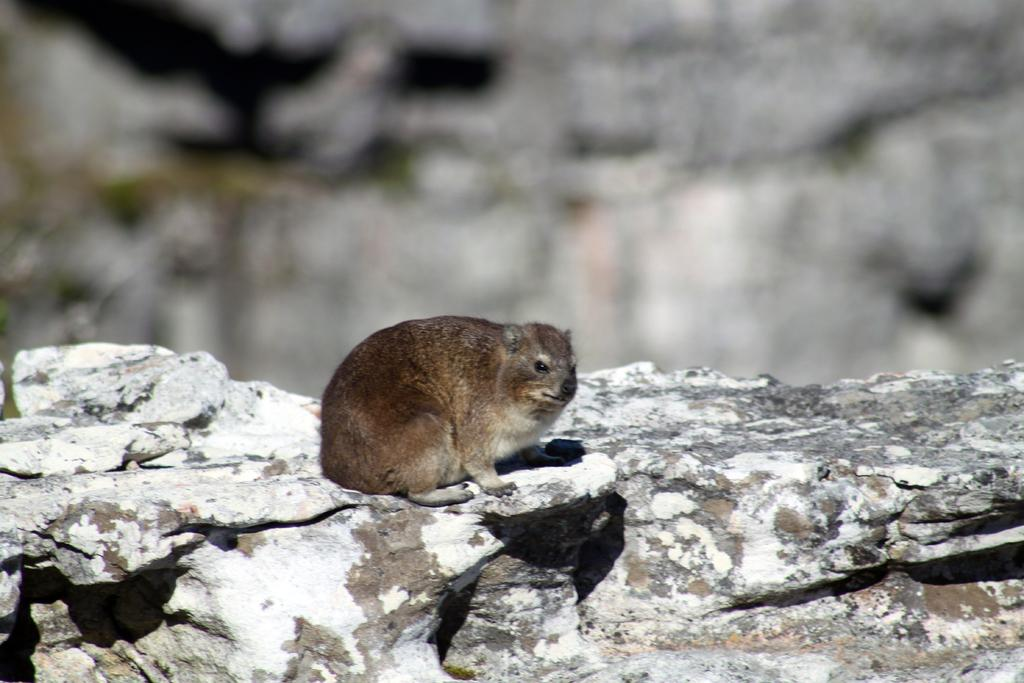What animal is present in the image? There is a mouse in the image. Where is the mouse located? The mouse is on a rock. How are the mouse and rock positioned in the image? The mouse and rock are in the center of the image. What type of silver is the mouse trading with the rock in the image? There is no silver or trading activity present in the image; it features a mouse on a rock. 